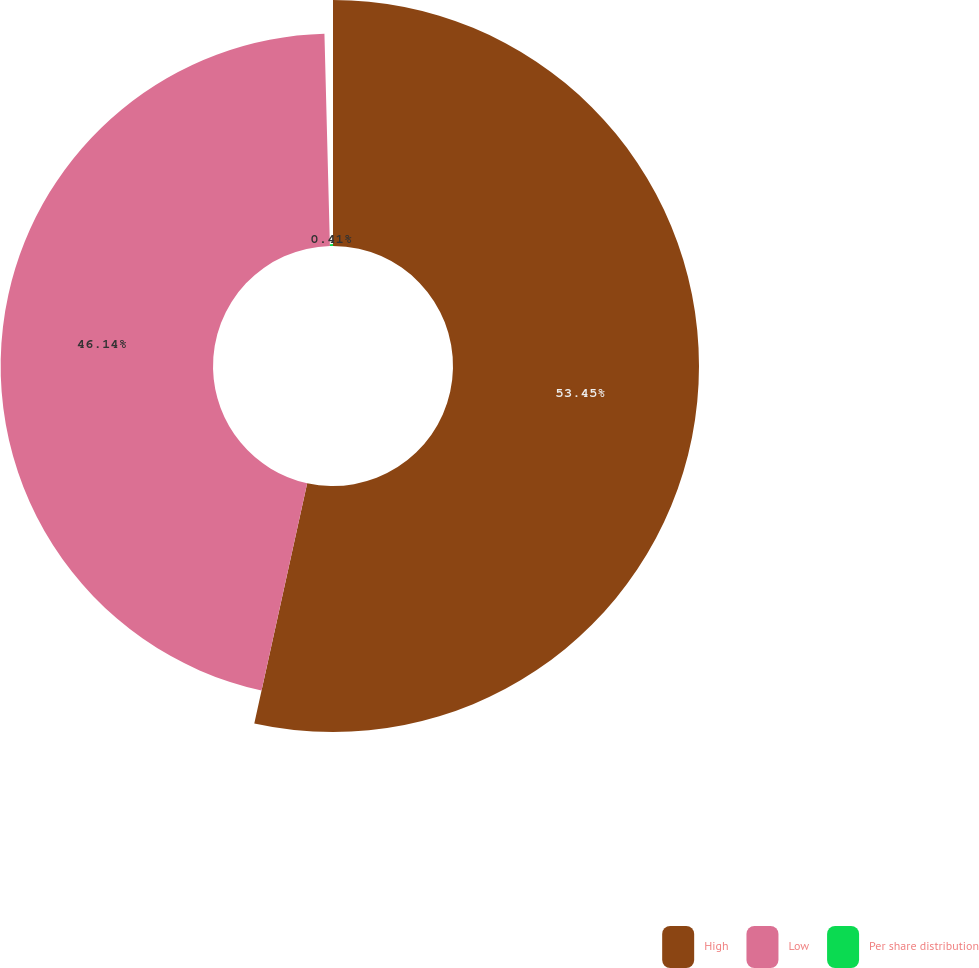Convert chart. <chart><loc_0><loc_0><loc_500><loc_500><pie_chart><fcel>High<fcel>Low<fcel>Per share distribution<nl><fcel>53.45%<fcel>46.14%<fcel>0.41%<nl></chart> 